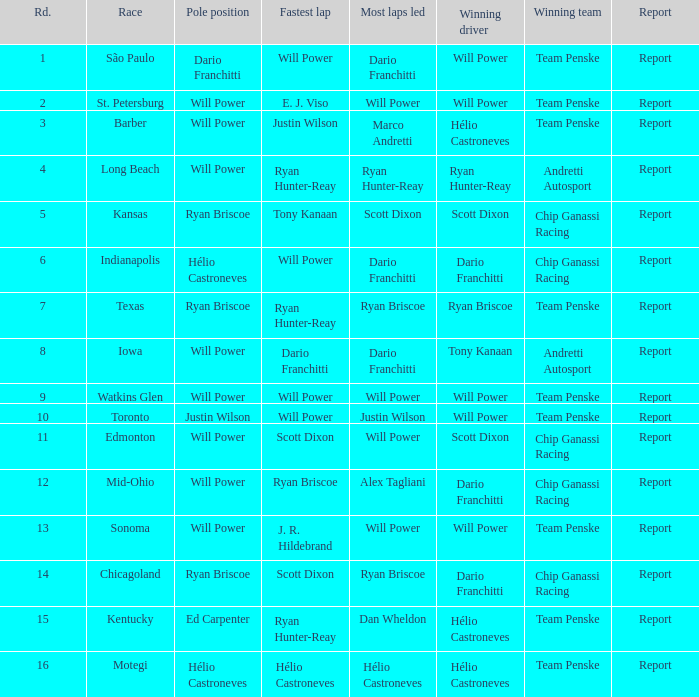Who was in the first place at chicagoland? Ryan Briscoe. 